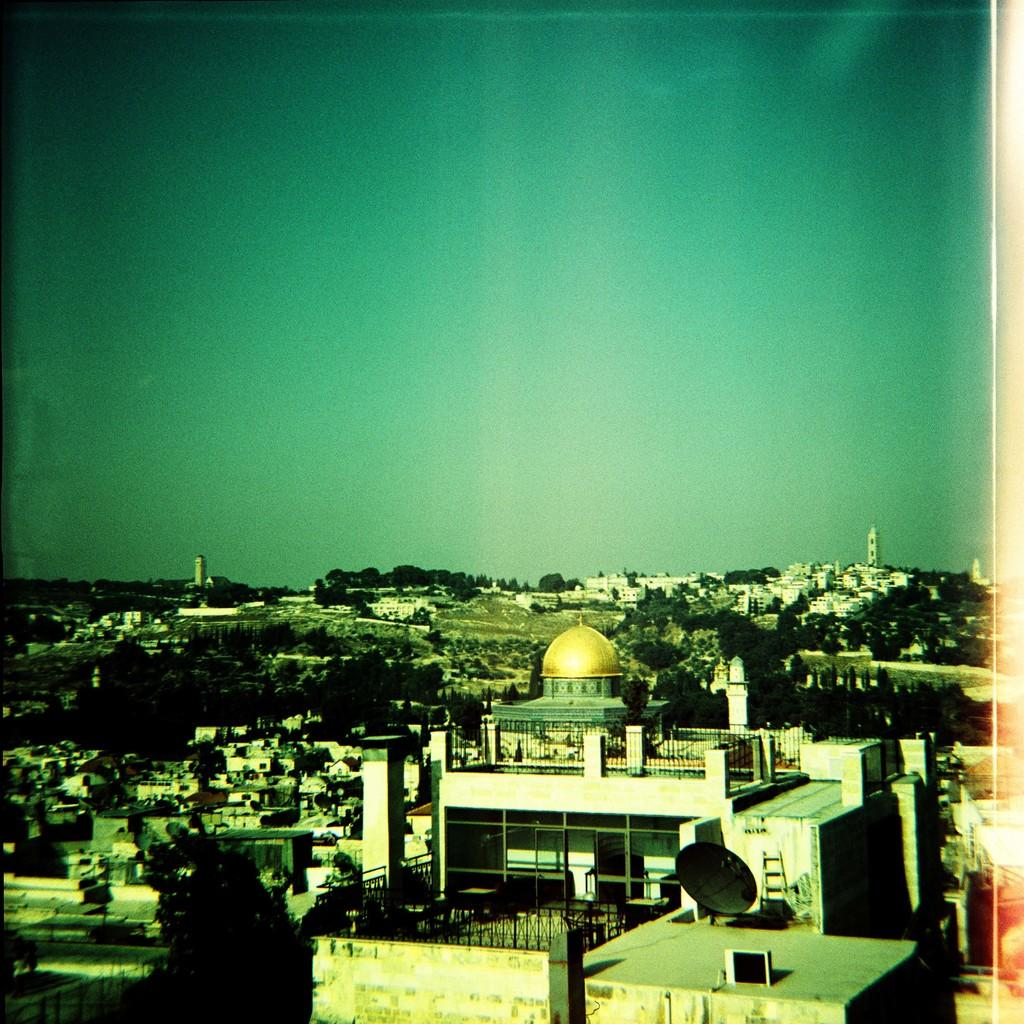What types of structures are located at the bottom of the image? There are buildings, trees, and houses at the bottom of the image. What can be seen in the sky at the top of the image? The sky is visible at the top of the image. What other features are present in the image besides the structures at the bottom? There are towers and poles in the image. How many yaks are grazing in the field in the image? There are no yaks present in the image; it features buildings, trees, houses, towers, and poles. What type of competition is taking place in the image? There is no competition present in the image. 